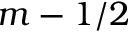Convert formula to latex. <formula><loc_0><loc_0><loc_500><loc_500>m - 1 / 2</formula> 